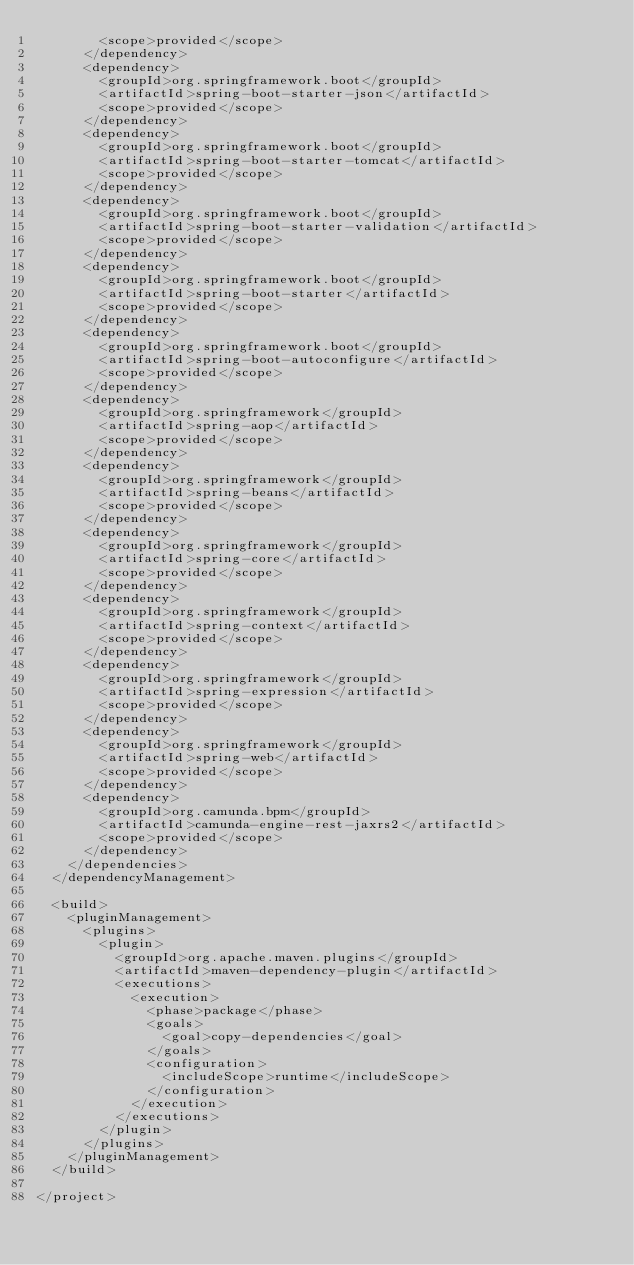<code> <loc_0><loc_0><loc_500><loc_500><_XML_>        <scope>provided</scope>
      </dependency>
      <dependency>
        <groupId>org.springframework.boot</groupId>
        <artifactId>spring-boot-starter-json</artifactId>
        <scope>provided</scope>
      </dependency>
      <dependency>
        <groupId>org.springframework.boot</groupId>
        <artifactId>spring-boot-starter-tomcat</artifactId>
        <scope>provided</scope>
      </dependency>
      <dependency>
        <groupId>org.springframework.boot</groupId>
        <artifactId>spring-boot-starter-validation</artifactId>
        <scope>provided</scope>
      </dependency>
      <dependency>
        <groupId>org.springframework.boot</groupId>
        <artifactId>spring-boot-starter</artifactId>
        <scope>provided</scope>
      </dependency>
      <dependency>
        <groupId>org.springframework.boot</groupId>
        <artifactId>spring-boot-autoconfigure</artifactId>
        <scope>provided</scope>
      </dependency>
      <dependency>
        <groupId>org.springframework</groupId>
        <artifactId>spring-aop</artifactId>
        <scope>provided</scope>
      </dependency>
      <dependency>
        <groupId>org.springframework</groupId>
        <artifactId>spring-beans</artifactId>
        <scope>provided</scope>
      </dependency>
      <dependency>
        <groupId>org.springframework</groupId>
        <artifactId>spring-core</artifactId>
        <scope>provided</scope>
      </dependency>
      <dependency>
        <groupId>org.springframework</groupId>
        <artifactId>spring-context</artifactId>
        <scope>provided</scope>
      </dependency>
      <dependency>
        <groupId>org.springframework</groupId>
        <artifactId>spring-expression</artifactId>
        <scope>provided</scope>
      </dependency>
      <dependency>
        <groupId>org.springframework</groupId>
        <artifactId>spring-web</artifactId>
        <scope>provided</scope>
      </dependency>
      <dependency>
        <groupId>org.camunda.bpm</groupId>
        <artifactId>camunda-engine-rest-jaxrs2</artifactId>
        <scope>provided</scope>
      </dependency>
    </dependencies>
  </dependencyManagement>

  <build>
    <pluginManagement>
      <plugins>
        <plugin>
          <groupId>org.apache.maven.plugins</groupId>
          <artifactId>maven-dependency-plugin</artifactId>
          <executions>
            <execution>
              <phase>package</phase>
              <goals>
                <goal>copy-dependencies</goal>
              </goals>
              <configuration>
                <includeScope>runtime</includeScope>
              </configuration>
            </execution>
          </executions>
        </plugin>
      </plugins>
    </pluginManagement>
  </build>

</project></code> 